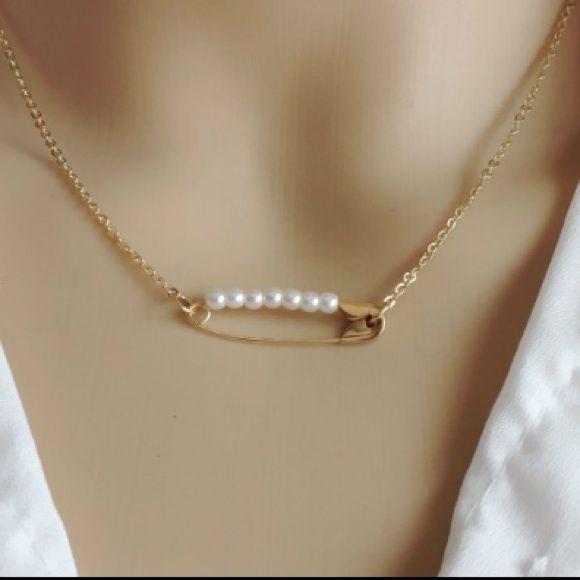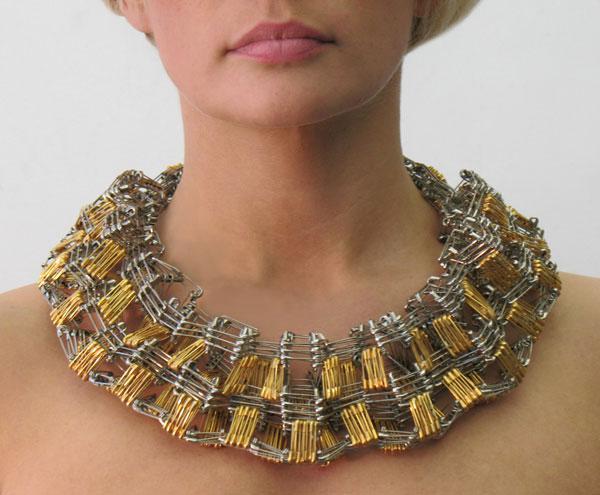The first image is the image on the left, the second image is the image on the right. Assess this claim about the two images: "one of the images only shows one safety pin.". Correct or not? Answer yes or no. Yes. The first image is the image on the left, the second image is the image on the right. For the images displayed, is the sentence "A necklace shown on a neck contains a pattern of square shapes made by repeating safety pin rows and contains gold and silver pins without beads strung on them." factually correct? Answer yes or no. Yes. 